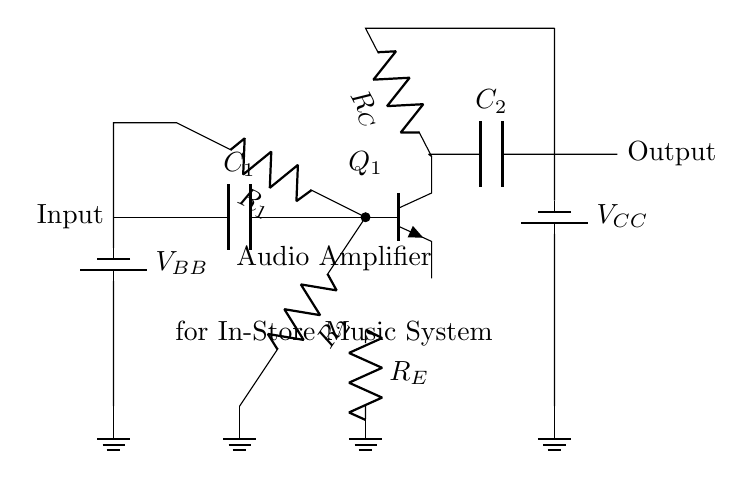What type of transistor is shown in the circuit? The circuit shows an NPN transistor, indicated by the symbol for the transistor with its terminals labeled in a specific arrangement.
Answer: NPN What is the purpose of capacitor C1 in the circuit? Capacitor C1 acts as a coupling capacitor; it allows AC signals (audio) to pass while blocking DC components. This ensures that only the audio signal is amplified.
Answer: AC coupling Which component is used to bias the transistor? The biasing is achieved using resistors R1 and R2, which form a voltage divider that supplies the base current necessary to operate the transistor in the active region.
Answer: Resistors R1 and R2 What is the role of the resistor R_E in this amplifier circuit? Resistor R_E provides stability for the transistor operation by setting the emitter current, which helps to stabilize the gain of the amplifier against variations in temperature and transistor parameters.
Answer: Stability What is the voltage level of supply V_CC in the circuit? V_CC is indicated as the supply voltage for the collector, which in typical audio amplifier designs is often around 12 to 15 volts, but the exact value is not specified in the diagram.
Answer: Not specified What is the output type of the audio amplifier? The output is a further amplified audio signal that results from the input audio after going through the transistor amplification process and coupling capacitor C2.
Answer: Amplified audio signal What components determine the gain of the amplifier in this circuit? The gain of the amplifier is mainly affected by resistor R_C and resistor R_E, where R_C is connected to the collector and R_E is connected to the emitter, creating feedback that determines the amplification factor.
Answer: Resistors R_C and R_E 